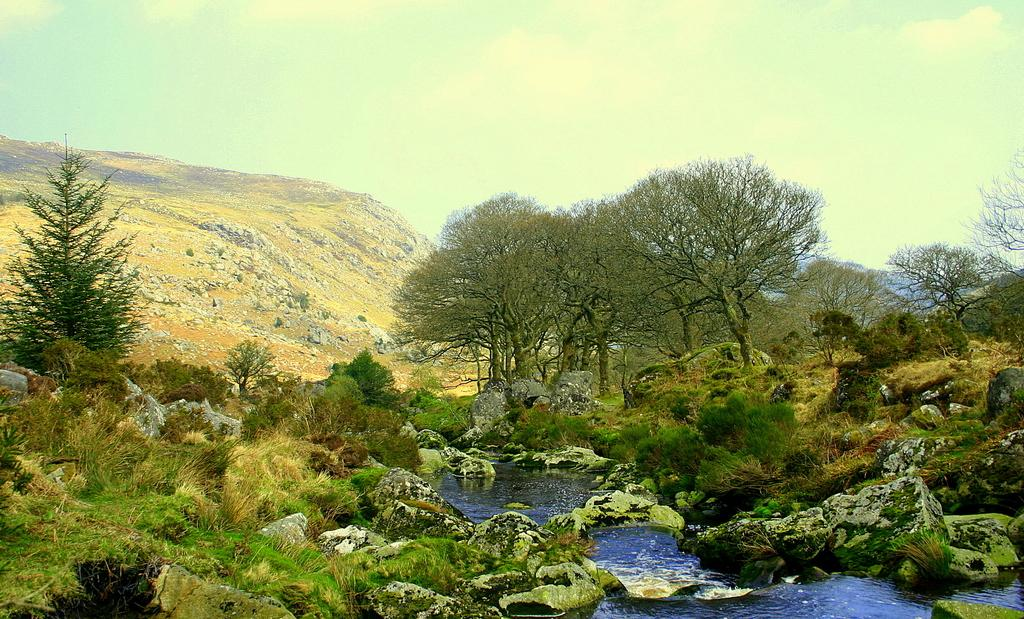What is the primary element in the picture? There is water in the picture. What other objects or features can be seen in the picture? There are stones, trees, and mountains in the picture. What is visible in the background of the picture? The sky is clear in the background of the picture. How many rabbits are hopping around the trees in the picture? There are no rabbits present in the picture; it features water, stones, trees, mountains, and a clear sky. 